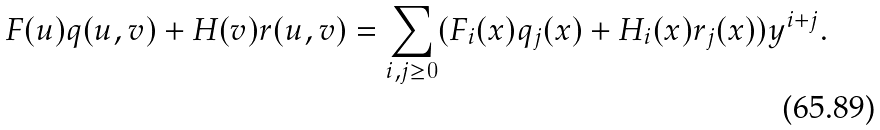<formula> <loc_0><loc_0><loc_500><loc_500>F ( u ) q ( u , v ) + H ( v ) r ( u , v ) = \sum _ { i , j \geq 0 } ( F _ { i } ( x ) q _ { j } ( x ) + H _ { i } ( x ) r _ { j } ( x ) ) y ^ { i + j } .</formula> 